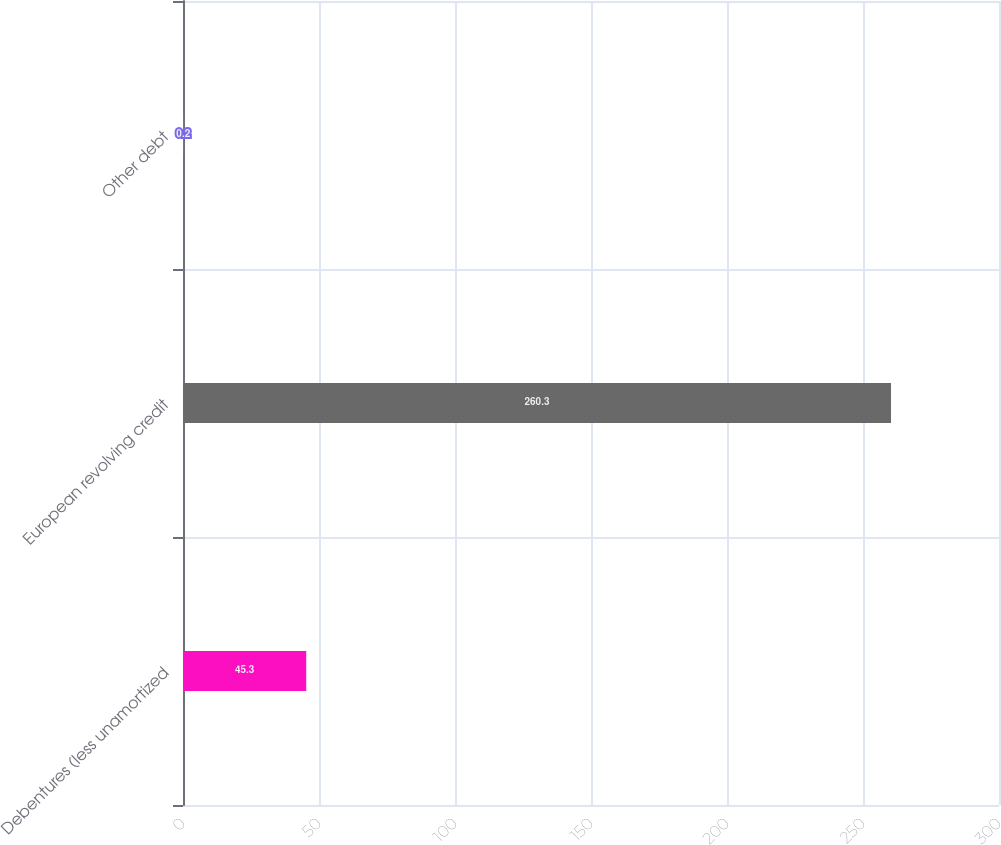Convert chart to OTSL. <chart><loc_0><loc_0><loc_500><loc_500><bar_chart><fcel>Debentures (less unamortized<fcel>European revolving credit<fcel>Other debt<nl><fcel>45.3<fcel>260.3<fcel>0.2<nl></chart> 